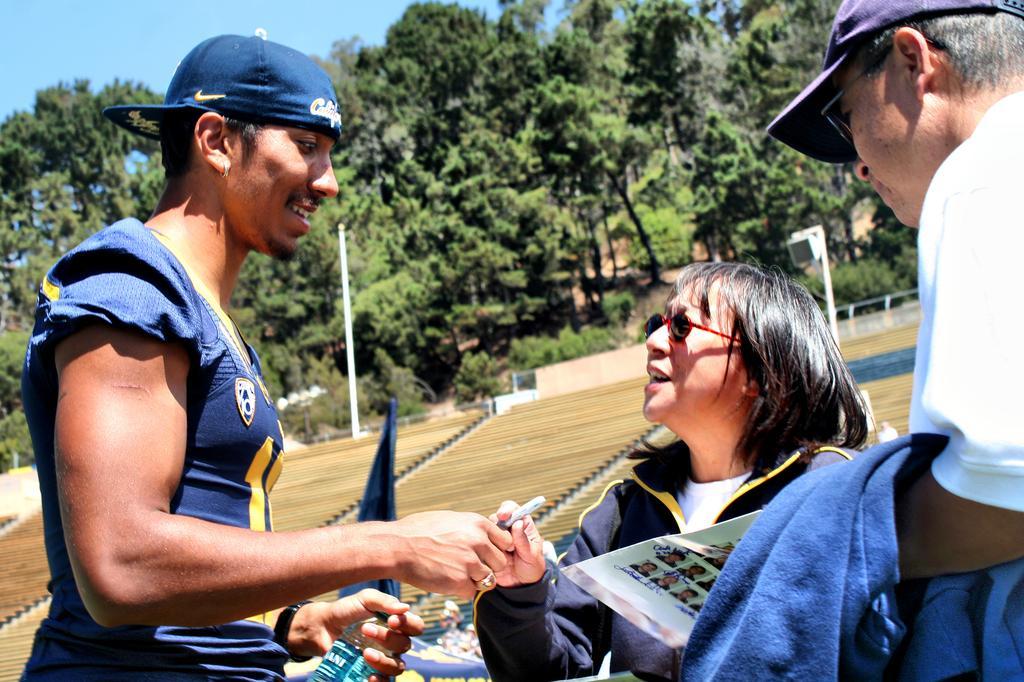Could you give a brief overview of what you see in this image? In this picture we can see three people, caps, goggles, pen, bottle, paper, clothes and in the background we can see poles, fences, trees, some objects and the sky. 